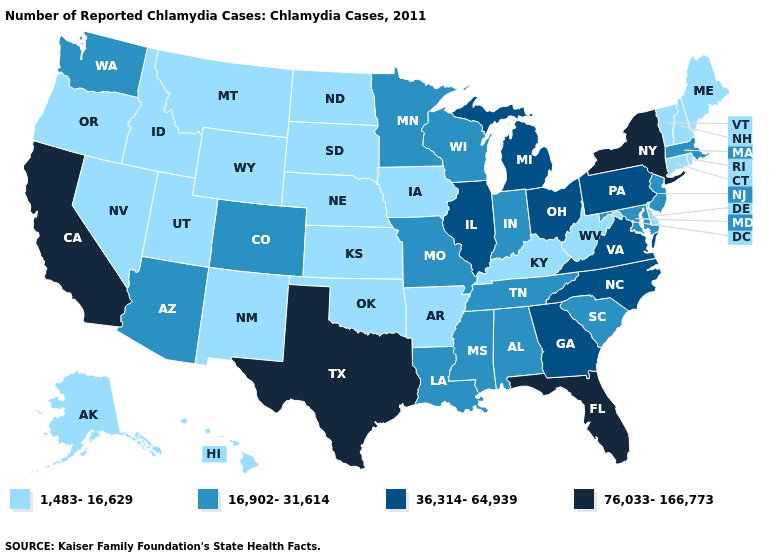Among the states that border Pennsylvania , which have the highest value?
Write a very short answer. New York. How many symbols are there in the legend?
Answer briefly. 4. Among the states that border Mississippi , does Arkansas have the highest value?
Quick response, please. No. Does Florida have the same value as Idaho?
Answer briefly. No. Which states have the lowest value in the MidWest?
Write a very short answer. Iowa, Kansas, Nebraska, North Dakota, South Dakota. What is the value of Illinois?
Be succinct. 36,314-64,939. What is the value of Alaska?
Answer briefly. 1,483-16,629. What is the value of Indiana?
Quick response, please. 16,902-31,614. Name the states that have a value in the range 36,314-64,939?
Give a very brief answer. Georgia, Illinois, Michigan, North Carolina, Ohio, Pennsylvania, Virginia. Name the states that have a value in the range 36,314-64,939?
Concise answer only. Georgia, Illinois, Michigan, North Carolina, Ohio, Pennsylvania, Virginia. Among the states that border Ohio , does Michigan have the highest value?
Keep it brief. Yes. Name the states that have a value in the range 1,483-16,629?
Write a very short answer. Alaska, Arkansas, Connecticut, Delaware, Hawaii, Idaho, Iowa, Kansas, Kentucky, Maine, Montana, Nebraska, Nevada, New Hampshire, New Mexico, North Dakota, Oklahoma, Oregon, Rhode Island, South Dakota, Utah, Vermont, West Virginia, Wyoming. Name the states that have a value in the range 76,033-166,773?
Keep it brief. California, Florida, New York, Texas. Which states hav the highest value in the Northeast?
Answer briefly. New York. What is the value of North Dakota?
Keep it brief. 1,483-16,629. 